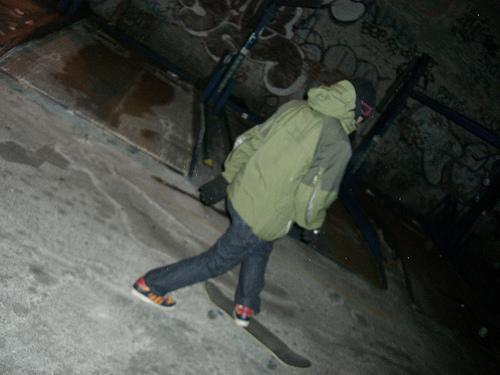Write a short sentence about the person's position on the skateboard. The person has their left foot on the skateboard and their right leg at the back, likely preparing to make a move. Comment on the appearance of the skateboard in the image. The skateboard is black with green wheels, and the person is standing on it while wearing black and red shoes. Describe the person's jeans observed in the image. The person is wearing blue jeans, which seem to be made of a classic denim fabric. Describe the activity the person in the image is performing and their surroundings. The individual is skateboarding outdoors, wearing a green coat and a dark hat, with a graffiti-covered wall in the background. Provide a brief description of the person in the image and their actions. A person in a green coat with a hood, black gloves, and blue jeans is skateboarding near a graffiti-covered wall. Explain the details of the person's footwear in the image. The person is wearing black and red shoes with an orange stripe, appearing to be a pair of sneakers. Highlight the accessories that the person in the image is wearing. The person is wearing a dark-colored hat, black gloves, and a green coat with a hood and zipper on the back of the sleeve. Mention the colors and elements of the person's outfit in the image. The person is wearing an olive green coat with a hood, dark hat, blue jeans, and black and red shoes with orange stripes. Mention the environment around the skateboarder in the image. The skateboarder is outside, near a wall with graffiti, and there is a visible section of concrete and a metal beam. Explain the color and style of the coat the person is wearing. The person is wearing a lime green coat with a hood, which appears to be warm and adequately insulated. 